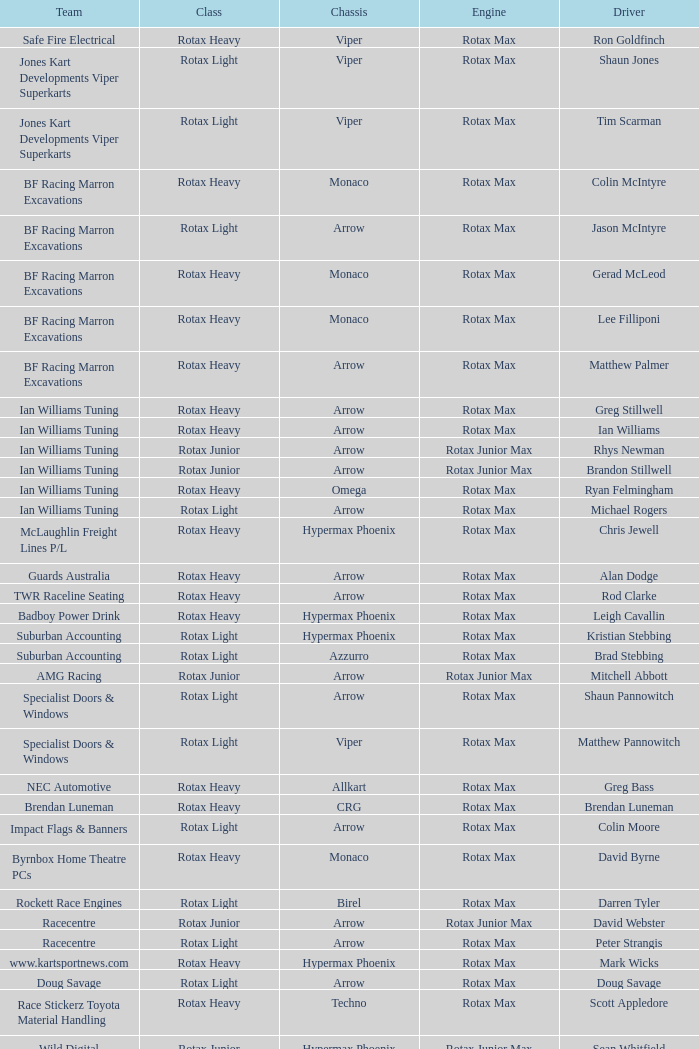Driver Shaun Jones with a viper as a chassis is in what class? Rotax Light. 